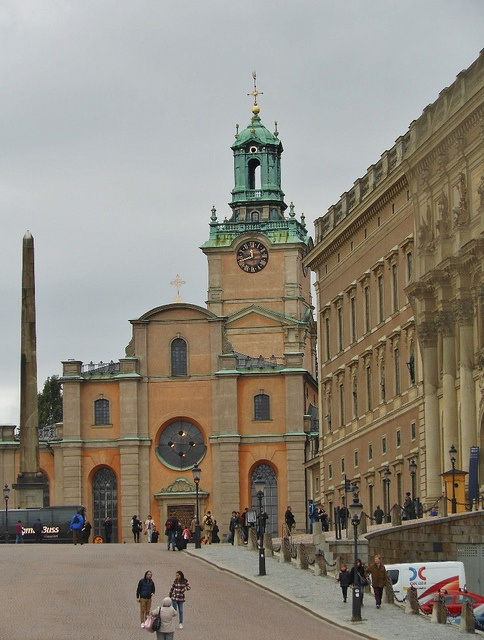Describe the objects in this image and their specific colors. I can see people in lightgray, black, gray, and darkgray tones, truck in lightgray, darkgray, and gray tones, car in lightgray, maroon, brown, and gray tones, clock in lightgray, black, and gray tones, and people in lightgray, black, maroon, and gray tones in this image. 